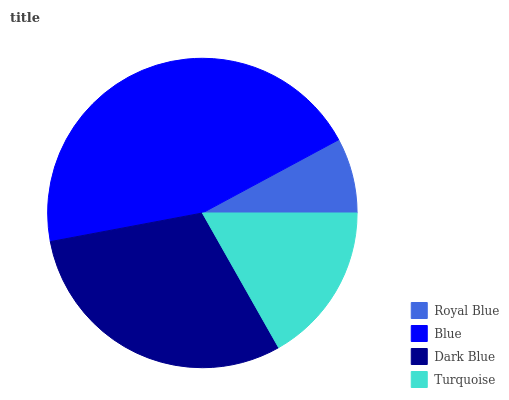Is Royal Blue the minimum?
Answer yes or no. Yes. Is Blue the maximum?
Answer yes or no. Yes. Is Dark Blue the minimum?
Answer yes or no. No. Is Dark Blue the maximum?
Answer yes or no. No. Is Blue greater than Dark Blue?
Answer yes or no. Yes. Is Dark Blue less than Blue?
Answer yes or no. Yes. Is Dark Blue greater than Blue?
Answer yes or no. No. Is Blue less than Dark Blue?
Answer yes or no. No. Is Dark Blue the high median?
Answer yes or no. Yes. Is Turquoise the low median?
Answer yes or no. Yes. Is Royal Blue the high median?
Answer yes or no. No. Is Blue the low median?
Answer yes or no. No. 